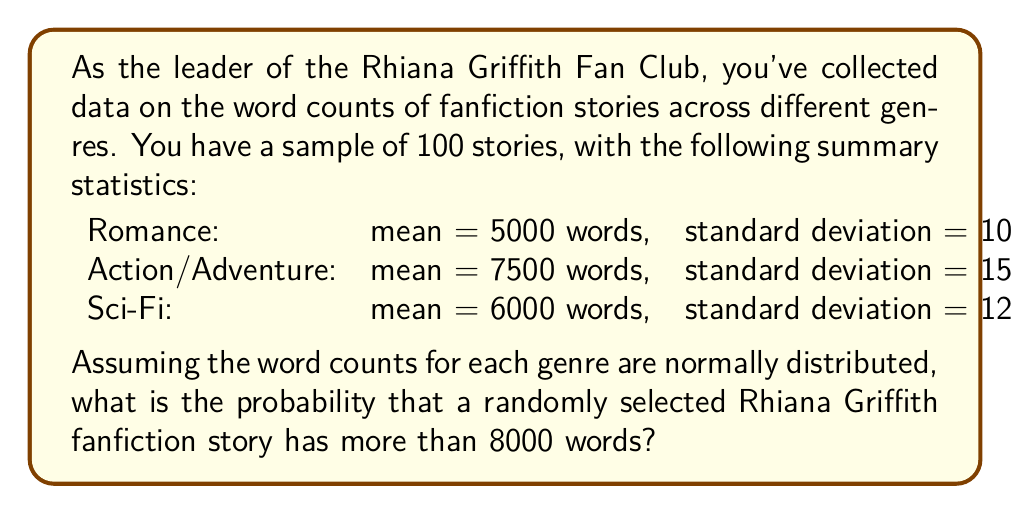Provide a solution to this math problem. To solve this problem, we need to follow these steps:

1. Calculate the probability for each genre separately.
2. Use the law of total probability to combine these results.

Let's start with each genre:

1. Romance:
   $z = \frac{8000 - 5000}{1000} = 3$
   $P(X > 8000) = 1 - \Phi(3) \approx 0.00135$

2. Action/Adventure:
   $z = \frac{8000 - 7500}{1500} = \frac{1}{3}$
   $P(X > 8000) = 1 - \Phi(\frac{1}{3}) \approx 0.3707$

3. Sci-Fi:
   $z = \frac{8000 - 6000}{1200} = \frac{5}{3}$
   $P(X > 8000) = 1 - \Phi(\frac{5}{3}) \approx 0.0475$

Now, assuming each genre is equally likely, we can use the law of total probability:

$$P(X > 8000) = \frac{1}{3}(0.00135 + 0.3707 + 0.0475) \approx 0.1398$$

Therefore, the probability that a randomly selected Rhiana Griffith fanfiction story has more than 8000 words is approximately 0.1398 or 13.98%.
Answer: 0.1398 